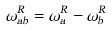Convert formula to latex. <formula><loc_0><loc_0><loc_500><loc_500>\omega _ { a b } ^ { R } = \omega _ { a } ^ { R } - \omega _ { b } ^ { R }</formula> 